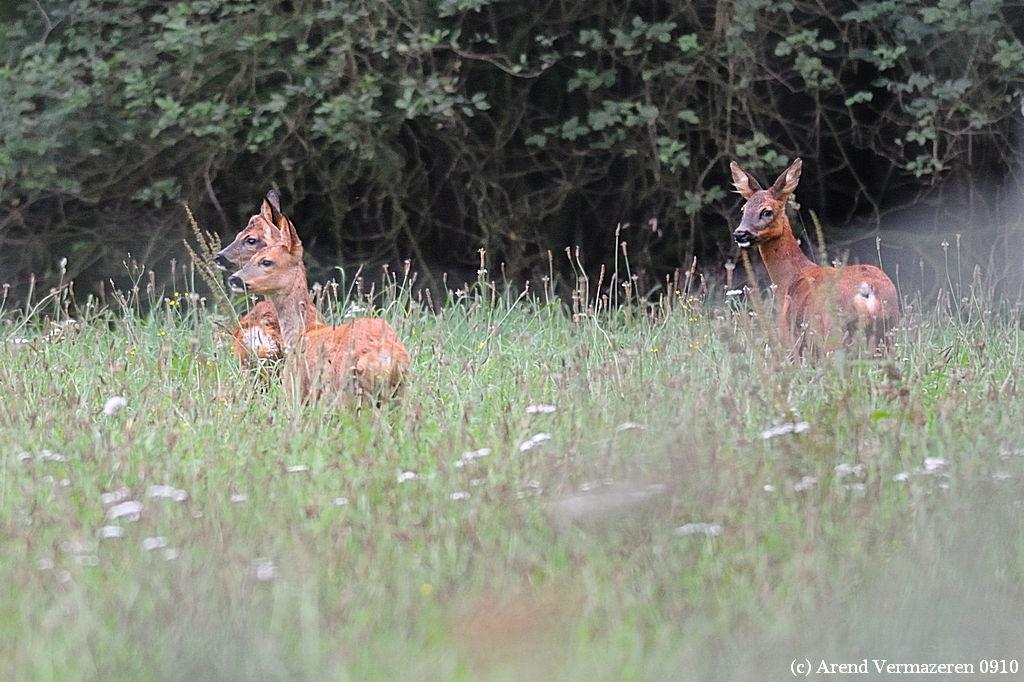How many animals are present in the image? There are three animals in the image. Can you describe the setting where the animals are located? The animals are in between the grass. What can be seen in the background of the image? There are many trees in the background of the image. What type of pizzas are the animals eating in the image? There are no pizzas present in the image; the animals are in between the grass and surrounded by trees. 